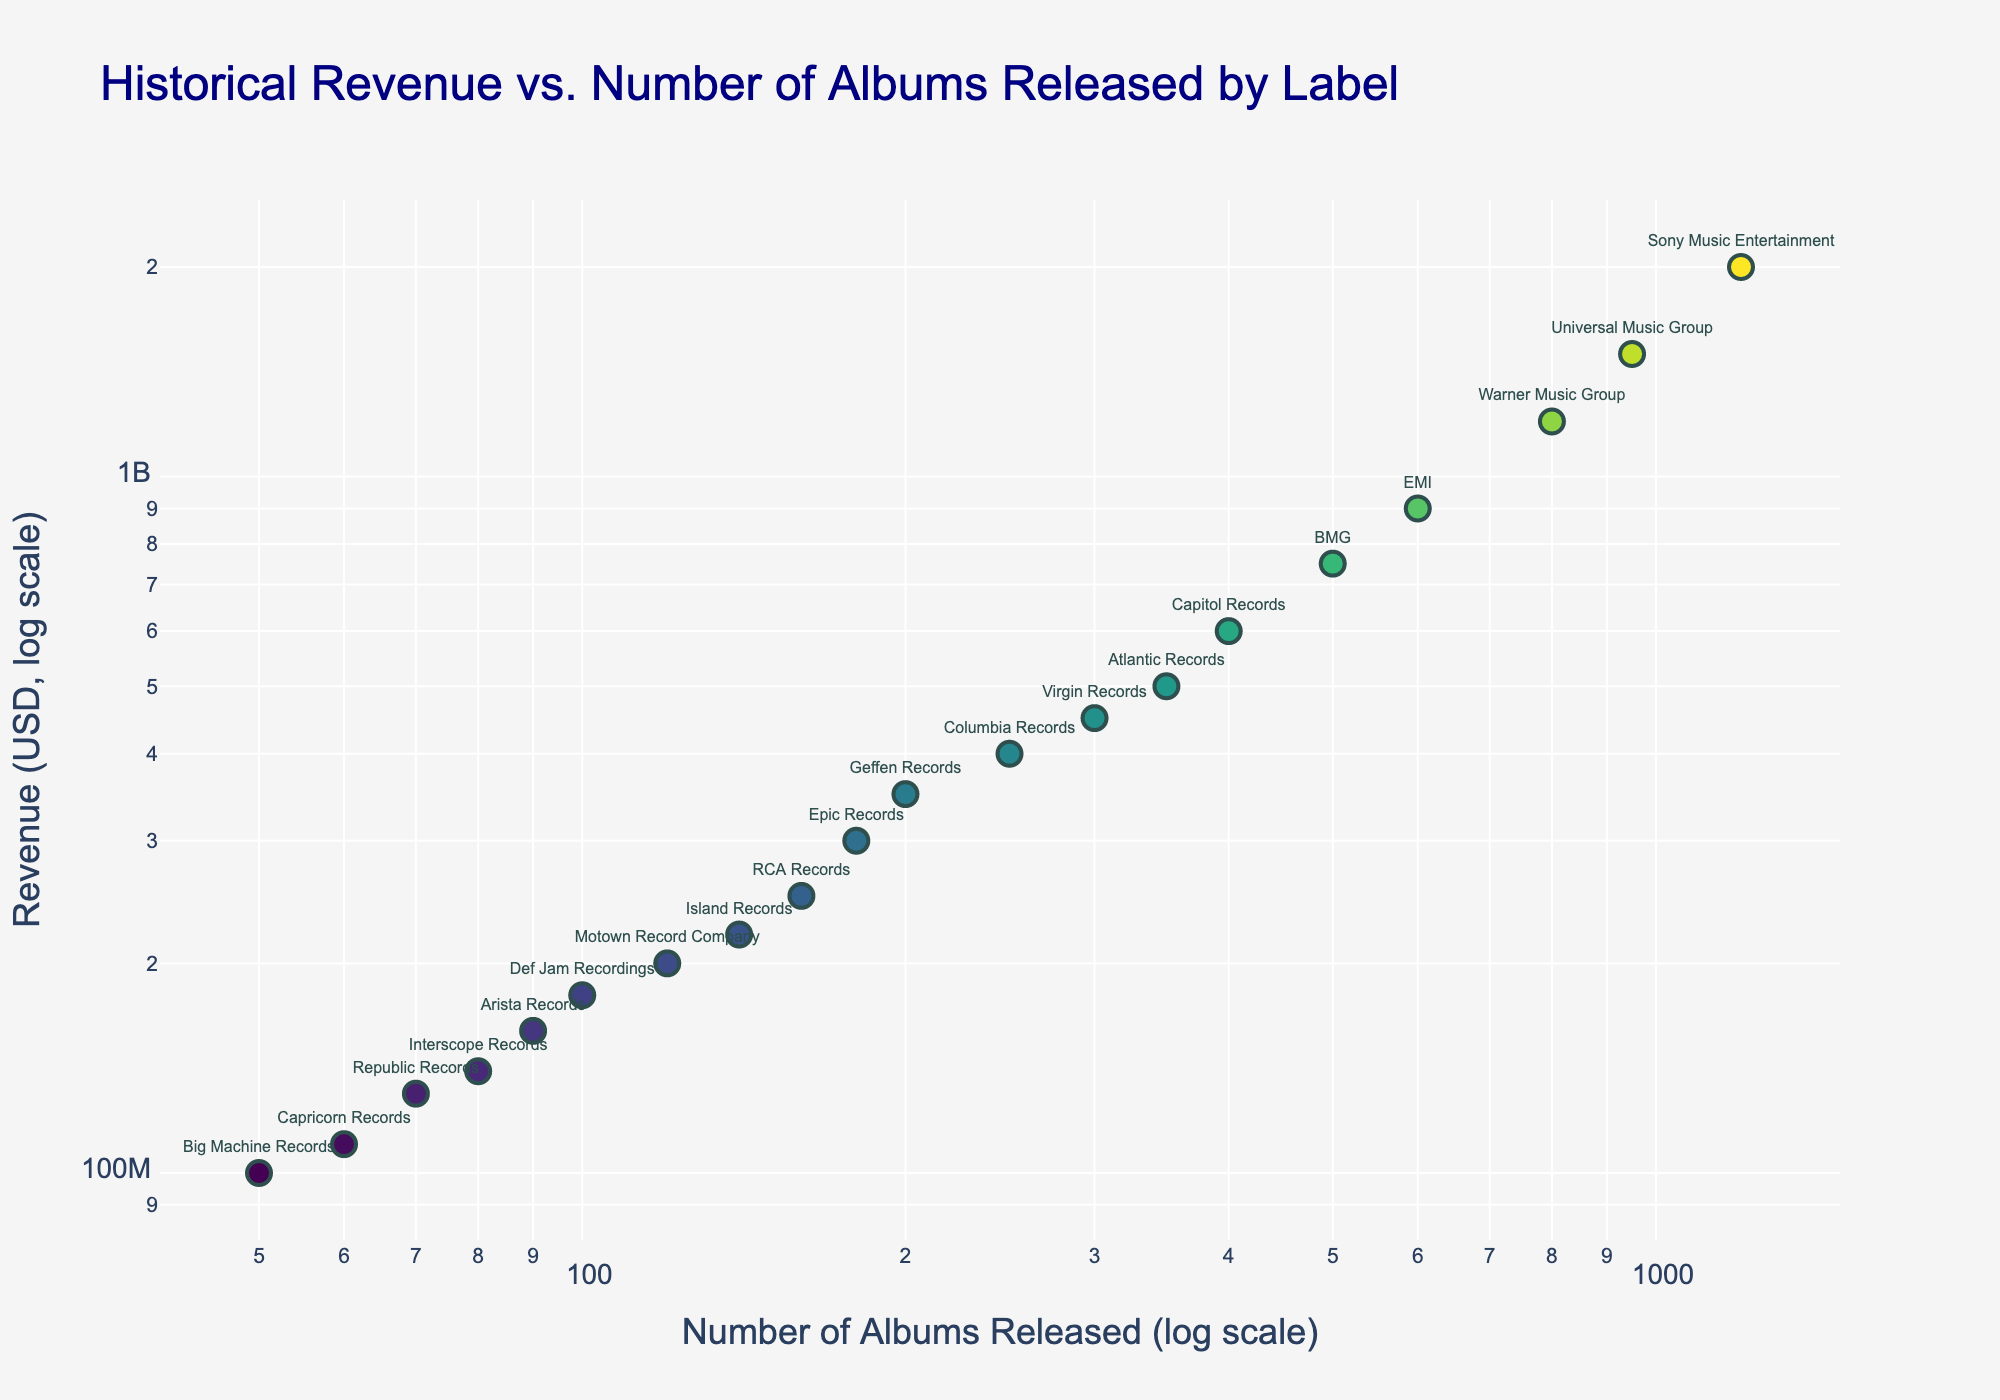What is the title of the scatter plot? The title is located at the top of the plot and provides information about the overall content.
Answer: Historical Revenue vs. Number of Albums Released by Label How many labels are plotted in the scatter plot? By counting the number of unique text labels associated with data points on the plot, we can determine the number of data points.
Answer: 20 Which label has the highest revenue, and what is its approximate value? Look for the data point that is the furthest up along the y-axis, then read the associated text label and revenue value.
Answer: Sony Music Entertainment, $2,000,000,000 Which label released the fewest number of albums? Find the data point that is the furthest left along the x-axis, then read the associated text label.
Answer: Big Machine Records What is the relationship between the number of albums released and the revenue generated? Observe if there's a notable trend or pattern in the scatter plot, particularly in the way points are distributed.
Answer: Generally, more albums correlate with higher revenue Which two labels have very similar revenues but different numbers of albums released? Identify two points that are at similar heights but different positions along the x-axis and check their associated labels.
Answer: Motown Record Company and Def Jam Recordings How does the revenue of Universal Music Group compare to Warner Music Group? Locate the points for both labels and compare their positions on the y-axis.
Answer: Universal Music Group has higher revenue Which labels fall around the middle of the scatter plot in terms of both number of albums and revenue? Look for data points positioned approximately in the center of the plot, then identify their labels.
Answer: Capitol Records and Atlantic Records Find the data range for the number of albums released. Determine the minimum and maximum values on the x-axis where data points are plotted.
Answer: From 50 to 1200 albums What can be inferred about labels with fewer than 100 albums released and their revenue? Examine the data points on the left side of the x-axis and note the range of their y-axis values.
Answer: Labels with fewer than 100 albums typically have revenues below $200,000,000 